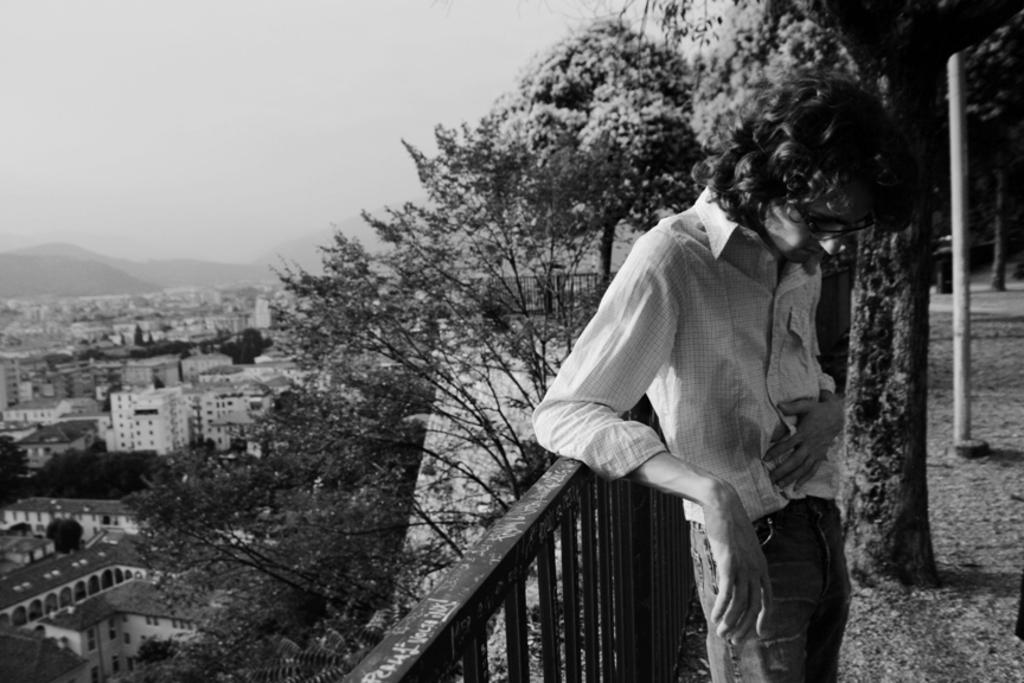What is the position of the man in the image? There is a man standing on the right side of the image. What can be seen in the middle of the image? There is railing in the middle of the image. What type of vegetation is on the left side of the image? There are trees on the left side of the image. What type of structures are on the left side of the image? There are buildings on the left side of the image. What is visible at the top of the image? The sky is visible at the top of the image. What action is the man's toe performing in the image? There is no specific action being performed by the man's toe in the image; it is simply part of his foot. Is there any exchange of goods or services taking place in the image? There is no exchange of goods or services depicted in the image. 